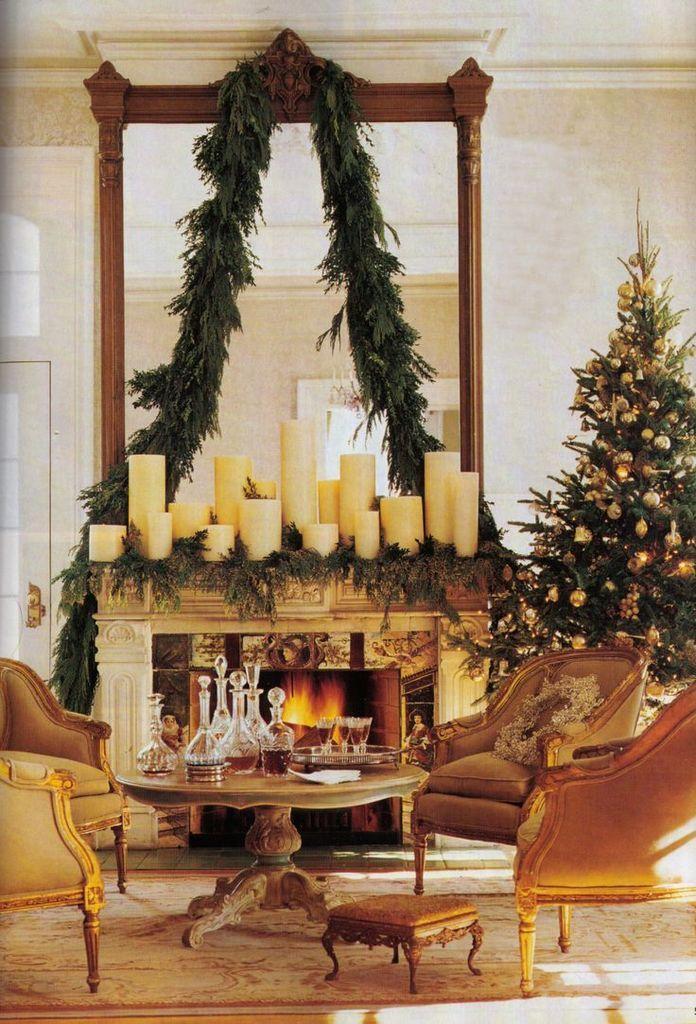In one or two sentences, can you explain what this image depicts? In this image I can see few couches, few bottles on the table. In the background I can see the Christmas tree and I can also see few decorative items, few candles and the wall is in white color. 